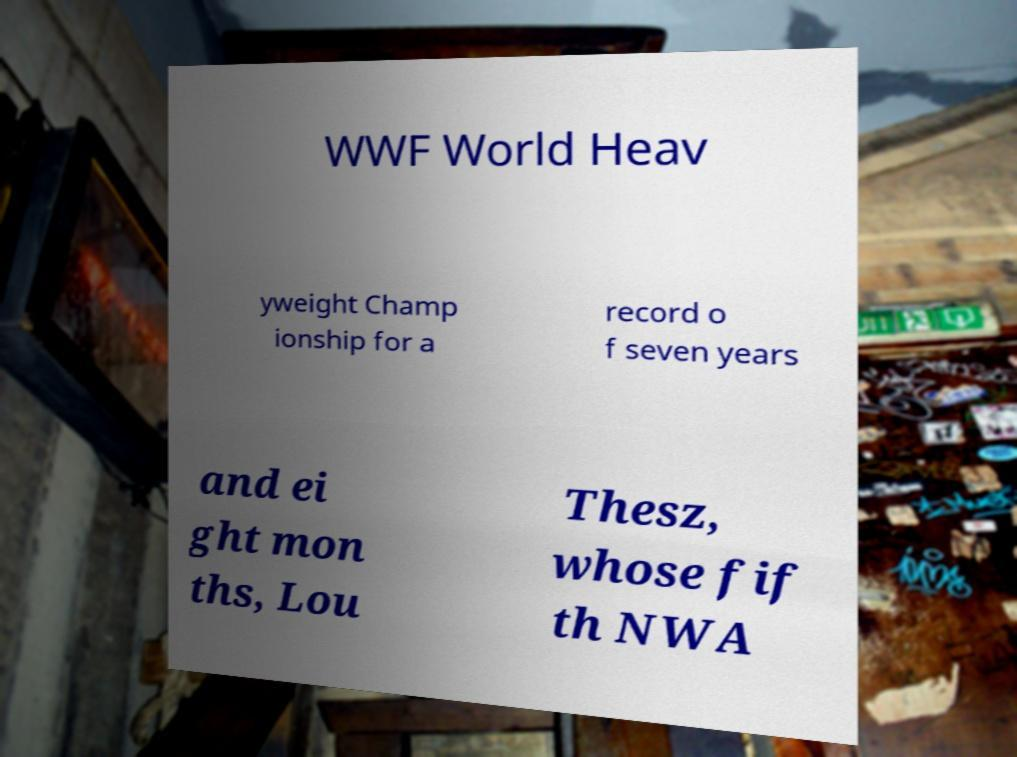Could you assist in decoding the text presented in this image and type it out clearly? WWF World Heav yweight Champ ionship for a record o f seven years and ei ght mon ths, Lou Thesz, whose fif th NWA 